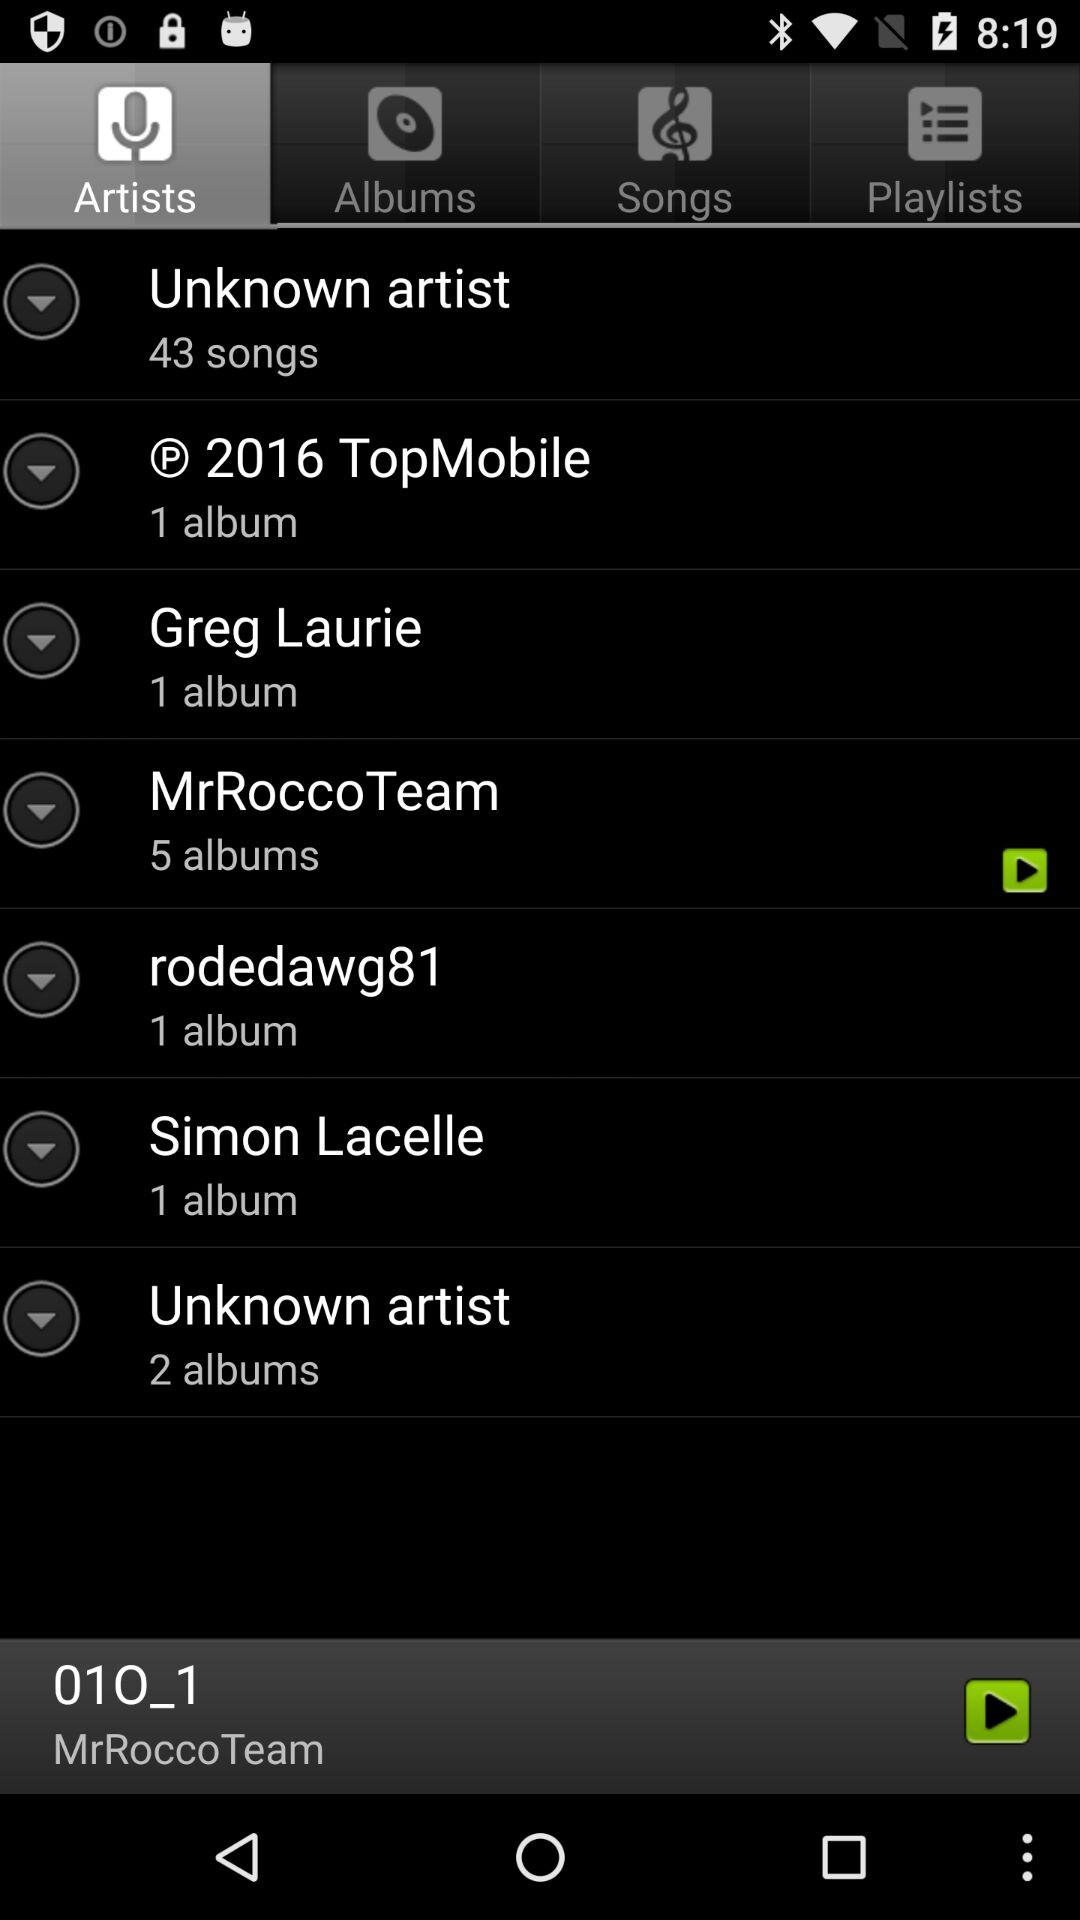How many albums does MrRocco Team have?
Answer the question using a single word or phrase. 5 